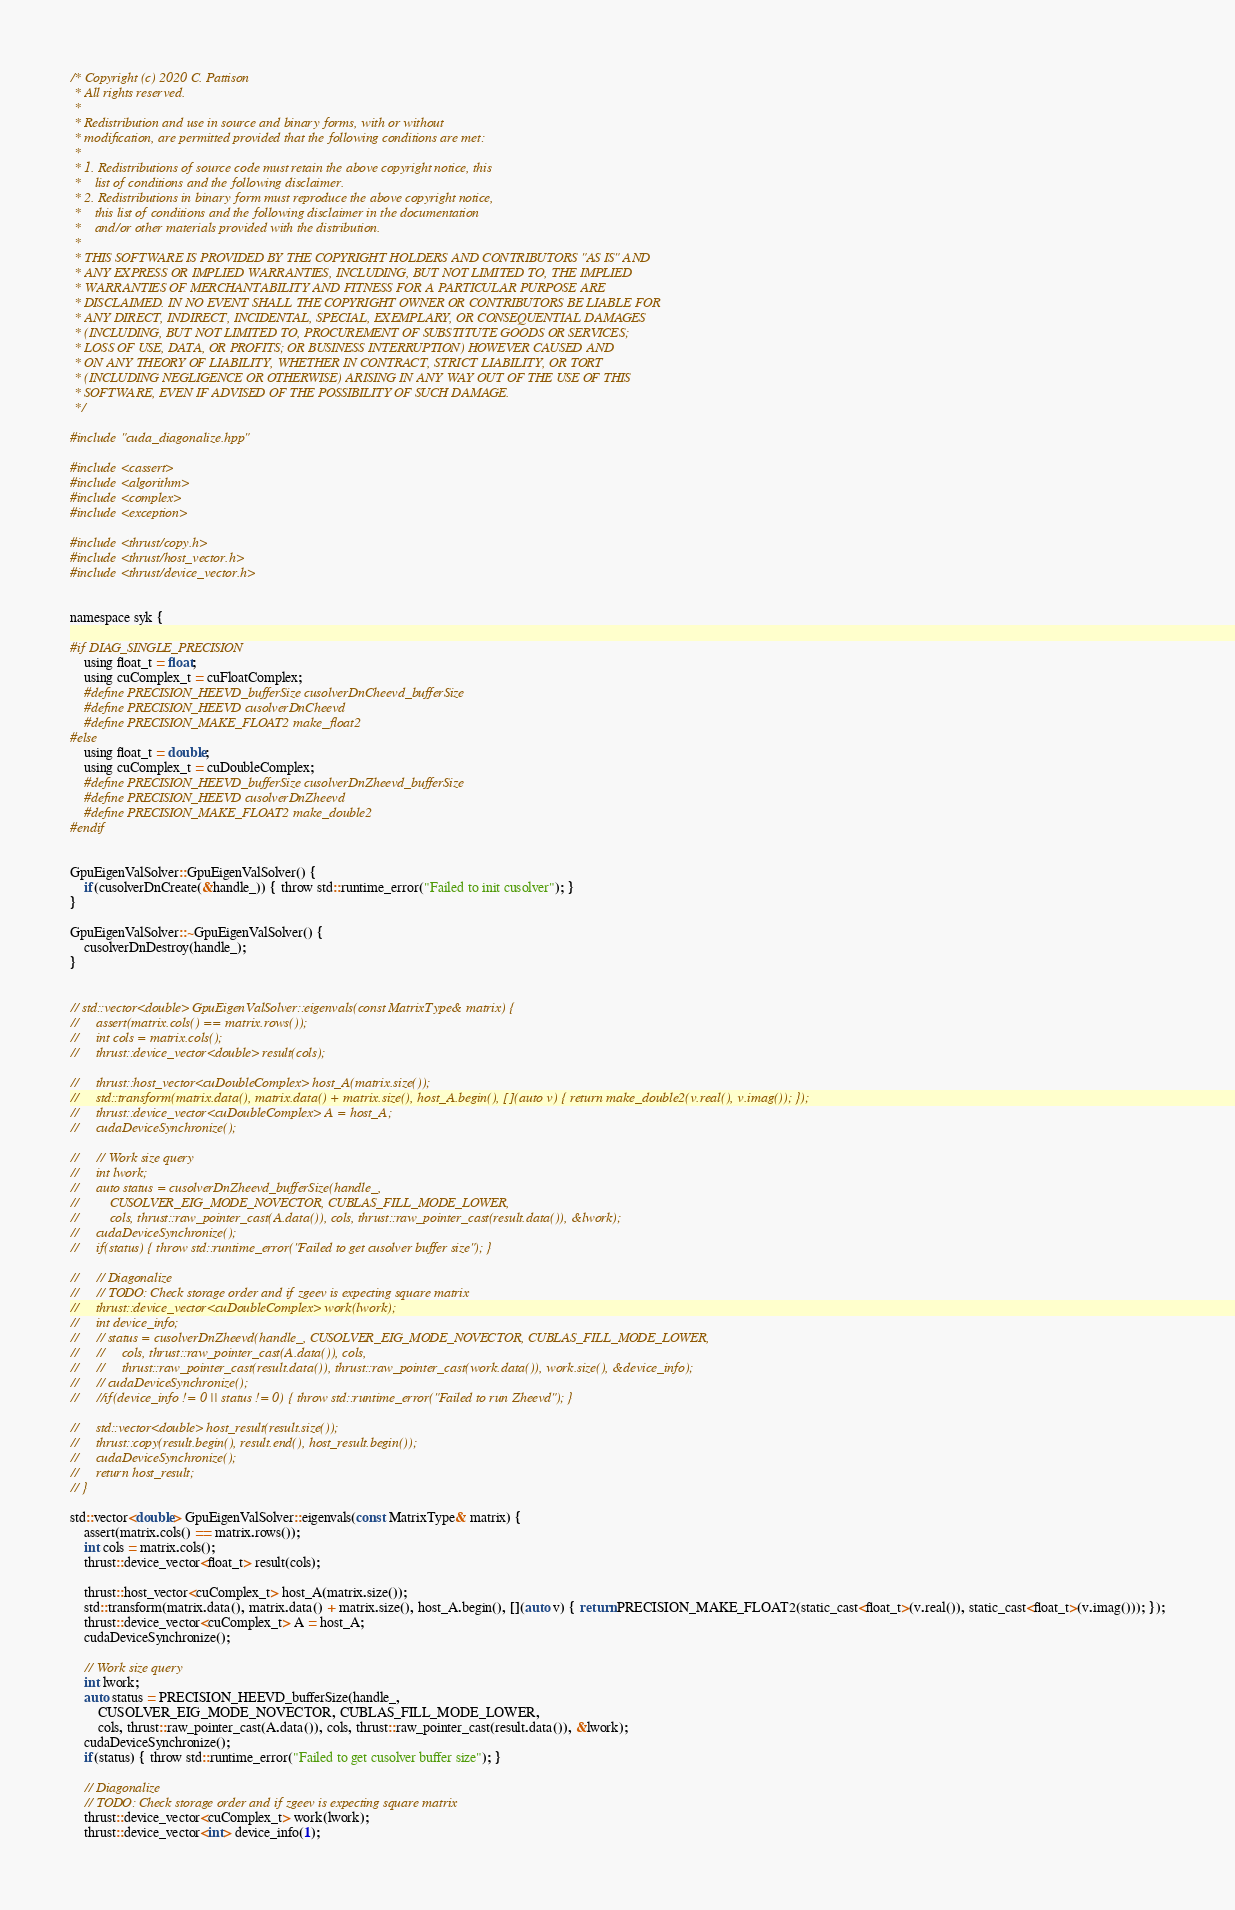<code> <loc_0><loc_0><loc_500><loc_500><_Cuda_>/* Copyright (c) 2020 C. Pattison
 * All rights reserved.
 * 
 * Redistribution and use in source and binary forms, with or without
 * modification, are permitted provided that the following conditions are met:
 * 
 * 1. Redistributions of source code must retain the above copyright notice, this
 *    list of conditions and the following disclaimer.
 * 2. Redistributions in binary form must reproduce the above copyright notice,
 *    this list of conditions and the following disclaimer in the documentation
 *    and/or other materials provided with the distribution.
 * 
 * THIS SOFTWARE IS PROVIDED BY THE COPYRIGHT HOLDERS AND CONTRIBUTORS "AS IS" AND
 * ANY EXPRESS OR IMPLIED WARRANTIES, INCLUDING, BUT NOT LIMITED TO, THE IMPLIED
 * WARRANTIES OF MERCHANTABILITY AND FITNESS FOR A PARTICULAR PURPOSE ARE
 * DISCLAIMED. IN NO EVENT SHALL THE COPYRIGHT OWNER OR CONTRIBUTORS BE LIABLE FOR
 * ANY DIRECT, INDIRECT, INCIDENTAL, SPECIAL, EXEMPLARY, OR CONSEQUENTIAL DAMAGES
 * (INCLUDING, BUT NOT LIMITED TO, PROCUREMENT OF SUBSTITUTE GOODS OR SERVICES;
 * LOSS OF USE, DATA, OR PROFITS; OR BUSINESS INTERRUPTION) HOWEVER CAUSED AND
 * ON ANY THEORY OF LIABILITY, WHETHER IN CONTRACT, STRICT LIABILITY, OR TORT
 * (INCLUDING NEGLIGENCE OR OTHERWISE) ARISING IN ANY WAY OUT OF THE USE OF THIS
 * SOFTWARE, EVEN IF ADVISED OF THE POSSIBILITY OF SUCH DAMAGE.
 */
 
#include "cuda_diagonalize.hpp"

#include <cassert>
#include <algorithm>
#include <complex>
#include <exception>

#include <thrust/copy.h>
#include <thrust/host_vector.h>
#include <thrust/device_vector.h>


namespace syk {

#if DIAG_SINGLE_PRECISION
    using float_t = float;
    using cuComplex_t = cuFloatComplex;
    #define PRECISION_HEEVD_bufferSize cusolverDnCheevd_bufferSize
    #define PRECISION_HEEVD cusolverDnCheevd
    #define PRECISION_MAKE_FLOAT2 make_float2
#else
    using float_t = double;
    using cuComplex_t = cuDoubleComplex;
    #define PRECISION_HEEVD_bufferSize cusolverDnZheevd_bufferSize
    #define PRECISION_HEEVD cusolverDnZheevd
    #define PRECISION_MAKE_FLOAT2 make_double2
#endif


GpuEigenValSolver::GpuEigenValSolver() {
    if(cusolverDnCreate(&handle_)) { throw std::runtime_error("Failed to init cusolver"); }
}

GpuEigenValSolver::~GpuEigenValSolver() {
    cusolverDnDestroy(handle_);
}


// std::vector<double> GpuEigenValSolver::eigenvals(const MatrixType& matrix) {
//     assert(matrix.cols() == matrix.rows());
//     int cols = matrix.cols();
//     thrust::device_vector<double> result(cols);

//     thrust::host_vector<cuDoubleComplex> host_A(matrix.size());
//     std::transform(matrix.data(), matrix.data() + matrix.size(), host_A.begin(), [](auto v) { return make_double2(v.real(), v.imag()); });
//     thrust::device_vector<cuDoubleComplex> A = host_A;
//     cudaDeviceSynchronize();

//     // Work size query
//     int lwork;
//     auto status = cusolverDnZheevd_bufferSize(handle_, 
//         CUSOLVER_EIG_MODE_NOVECTOR, CUBLAS_FILL_MODE_LOWER, 
//         cols, thrust::raw_pointer_cast(A.data()), cols, thrust::raw_pointer_cast(result.data()), &lwork);
//     cudaDeviceSynchronize();
//     if(status) { throw std::runtime_error("Failed to get cusolver buffer size"); }

//     // Diagonalize
//     // TODO: Check storage order and if zgeev is expecting square matrix 
//     thrust::device_vector<cuDoubleComplex> work(lwork);
//     int device_info;
//     // status = cusolverDnZheevd(handle_, CUSOLVER_EIG_MODE_NOVECTOR, CUBLAS_FILL_MODE_LOWER,
//     //     cols, thrust::raw_pointer_cast(A.data()), cols, 
//     //     thrust::raw_pointer_cast(result.data()), thrust::raw_pointer_cast(work.data()), work.size(), &device_info);
//     // cudaDeviceSynchronize();
//     //if(device_info != 0 || status != 0) { throw std::runtime_error("Failed to run Zheevd"); }
   
//     std::vector<double> host_result(result.size());
//     thrust::copy(result.begin(), result.end(), host_result.begin());
//     cudaDeviceSynchronize();
//     return host_result;
// }

std::vector<double> GpuEigenValSolver::eigenvals(const MatrixType& matrix) {
    assert(matrix.cols() == matrix.rows());
    int cols = matrix.cols();
    thrust::device_vector<float_t> result(cols);

    thrust::host_vector<cuComplex_t> host_A(matrix.size());
    std::transform(matrix.data(), matrix.data() + matrix.size(), host_A.begin(), [](auto v) { return PRECISION_MAKE_FLOAT2(static_cast<float_t>(v.real()), static_cast<float_t>(v.imag())); });
    thrust::device_vector<cuComplex_t> A = host_A;
    cudaDeviceSynchronize();

    // Work size query
    int lwork;
    auto status = PRECISION_HEEVD_bufferSize(handle_, 
        CUSOLVER_EIG_MODE_NOVECTOR, CUBLAS_FILL_MODE_LOWER, 
        cols, thrust::raw_pointer_cast(A.data()), cols, thrust::raw_pointer_cast(result.data()), &lwork);
    cudaDeviceSynchronize();
    if(status) { throw std::runtime_error("Failed to get cusolver buffer size"); }

    // Diagonalize
    // TODO: Check storage order and if zgeev is expecting square matrix 
    thrust::device_vector<cuComplex_t> work(lwork);
    thrust::device_vector<int> device_info(1);</code> 